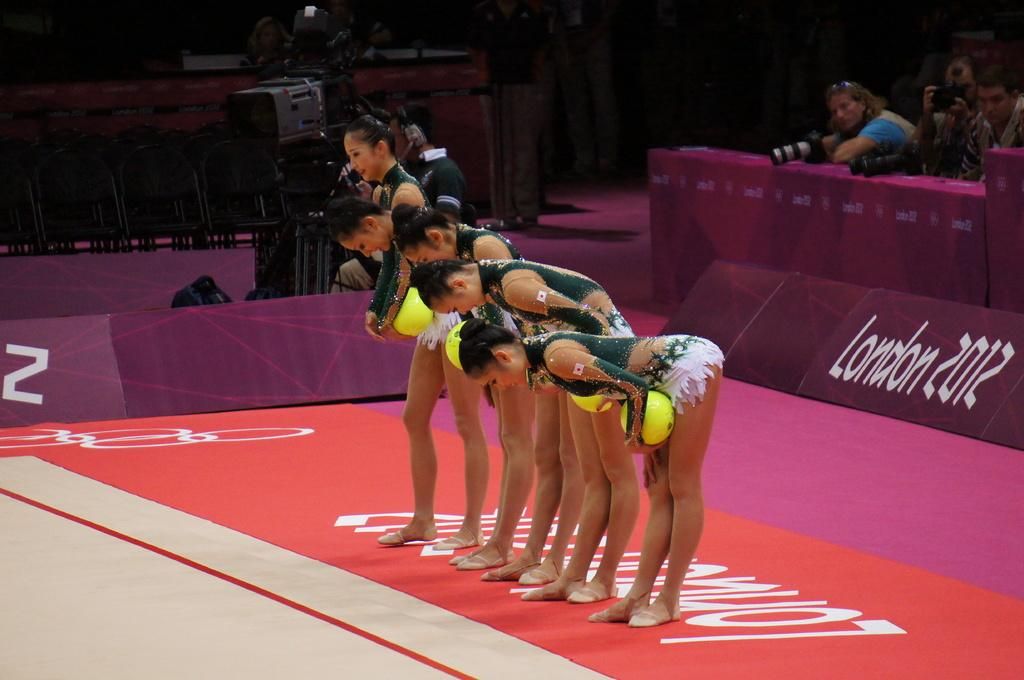Provide a one-sentence caption for the provided image. Five Asian female sports players are bowing in a line up, with London 2012 written on the flooring and in back of them. 